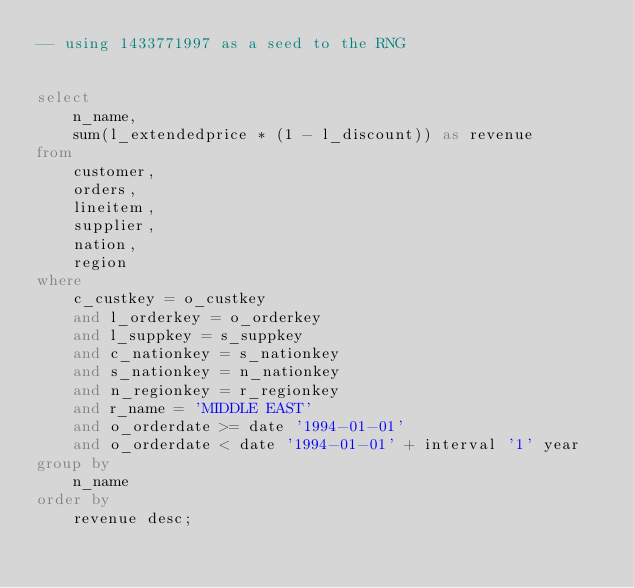<code> <loc_0><loc_0><loc_500><loc_500><_SQL_>-- using 1433771997 as a seed to the RNG


select
    n_name,
    sum(l_extendedprice * (1 - l_discount)) as revenue
from
    customer,
    orders,
    lineitem,
    supplier,
    nation,
    region
where
    c_custkey = o_custkey
    and l_orderkey = o_orderkey
    and l_suppkey = s_suppkey
    and c_nationkey = s_nationkey
    and s_nationkey = n_nationkey
    and n_regionkey = r_regionkey
    and r_name = 'MIDDLE EAST'
    and o_orderdate >= date '1994-01-01'
    and o_orderdate < date '1994-01-01' + interval '1' year
group by
    n_name
order by
    revenue desc;

</code> 